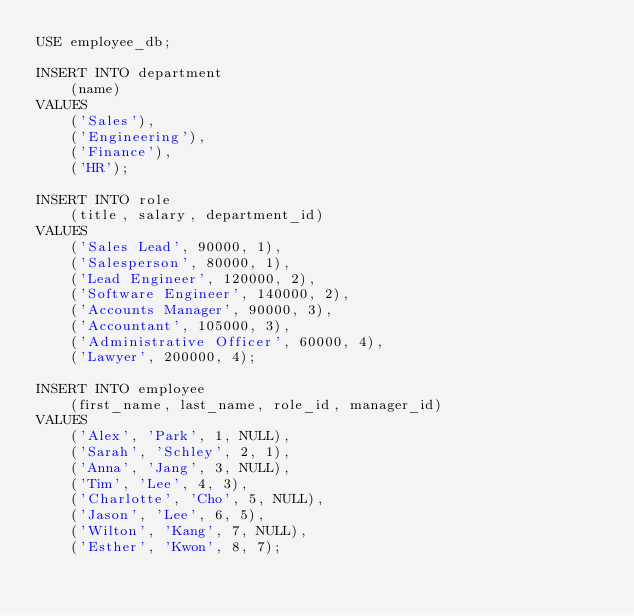<code> <loc_0><loc_0><loc_500><loc_500><_SQL_>USE employee_db;

INSERT INTO department
    (name)
VALUES
    ('Sales'),
    ('Engineering'),
    ('Finance'),
    ('HR');

INSERT INTO role
    (title, salary, department_id)
VALUES
    ('Sales Lead', 90000, 1),
    ('Salesperson', 80000, 1),
    ('Lead Engineer', 120000, 2),
    ('Software Engineer', 140000, 2),
    ('Accounts Manager', 90000, 3),
    ('Accountant', 105000, 3),
    ('Administrative Officer', 60000, 4),
    ('Lawyer', 200000, 4);

INSERT INTO employee
    (first_name, last_name, role_id, manager_id)
VALUES
    ('Alex', 'Park', 1, NULL),
    ('Sarah', 'Schley', 2, 1),
    ('Anna', 'Jang', 3, NULL),
    ('Tim', 'Lee', 4, 3),
    ('Charlotte', 'Cho', 5, NULL),
    ('Jason', 'Lee', 6, 5),
    ('Wilton', 'Kang', 7, NULL),
    ('Esther', 'Kwon', 8, 7);</code> 